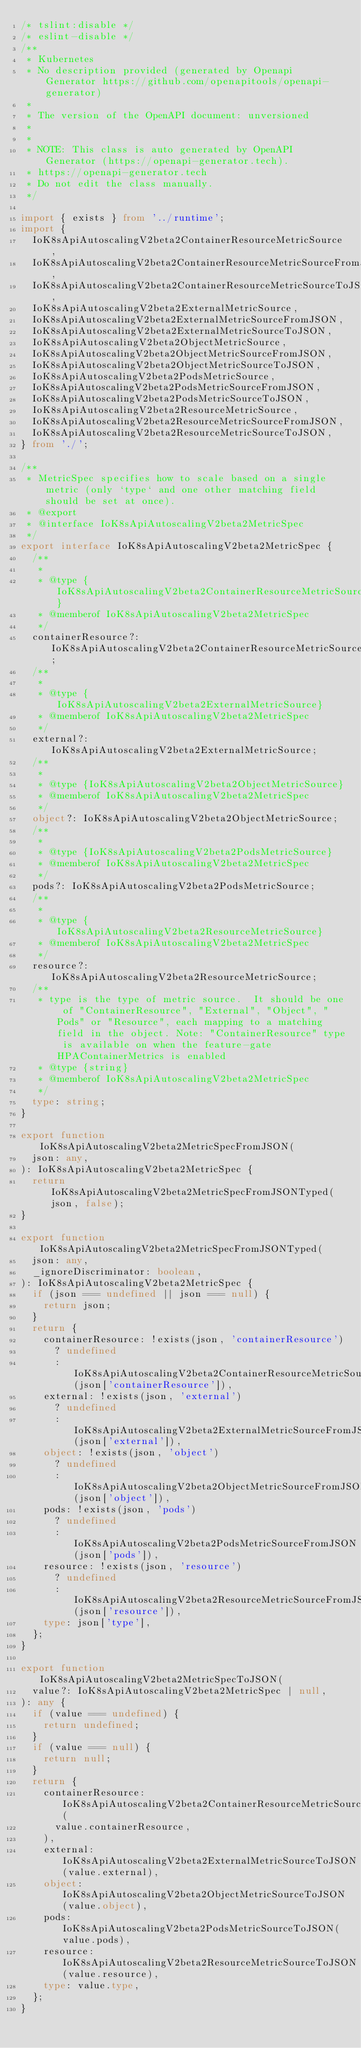<code> <loc_0><loc_0><loc_500><loc_500><_TypeScript_>/* tslint:disable */
/* eslint-disable */
/**
 * Kubernetes
 * No description provided (generated by Openapi Generator https://github.com/openapitools/openapi-generator)
 *
 * The version of the OpenAPI document: unversioned
 *
 *
 * NOTE: This class is auto generated by OpenAPI Generator (https://openapi-generator.tech).
 * https://openapi-generator.tech
 * Do not edit the class manually.
 */

import { exists } from '../runtime';
import {
  IoK8sApiAutoscalingV2beta2ContainerResourceMetricSource,
  IoK8sApiAutoscalingV2beta2ContainerResourceMetricSourceFromJSON,
  IoK8sApiAutoscalingV2beta2ContainerResourceMetricSourceToJSON,
  IoK8sApiAutoscalingV2beta2ExternalMetricSource,
  IoK8sApiAutoscalingV2beta2ExternalMetricSourceFromJSON,
  IoK8sApiAutoscalingV2beta2ExternalMetricSourceToJSON,
  IoK8sApiAutoscalingV2beta2ObjectMetricSource,
  IoK8sApiAutoscalingV2beta2ObjectMetricSourceFromJSON,
  IoK8sApiAutoscalingV2beta2ObjectMetricSourceToJSON,
  IoK8sApiAutoscalingV2beta2PodsMetricSource,
  IoK8sApiAutoscalingV2beta2PodsMetricSourceFromJSON,
  IoK8sApiAutoscalingV2beta2PodsMetricSourceToJSON,
  IoK8sApiAutoscalingV2beta2ResourceMetricSource,
  IoK8sApiAutoscalingV2beta2ResourceMetricSourceFromJSON,
  IoK8sApiAutoscalingV2beta2ResourceMetricSourceToJSON,
} from './';

/**
 * MetricSpec specifies how to scale based on a single metric (only `type` and one other matching field should be set at once).
 * @export
 * @interface IoK8sApiAutoscalingV2beta2MetricSpec
 */
export interface IoK8sApiAutoscalingV2beta2MetricSpec {
  /**
   *
   * @type {IoK8sApiAutoscalingV2beta2ContainerResourceMetricSource}
   * @memberof IoK8sApiAutoscalingV2beta2MetricSpec
   */
  containerResource?: IoK8sApiAutoscalingV2beta2ContainerResourceMetricSource;
  /**
   *
   * @type {IoK8sApiAutoscalingV2beta2ExternalMetricSource}
   * @memberof IoK8sApiAutoscalingV2beta2MetricSpec
   */
  external?: IoK8sApiAutoscalingV2beta2ExternalMetricSource;
  /**
   *
   * @type {IoK8sApiAutoscalingV2beta2ObjectMetricSource}
   * @memberof IoK8sApiAutoscalingV2beta2MetricSpec
   */
  object?: IoK8sApiAutoscalingV2beta2ObjectMetricSource;
  /**
   *
   * @type {IoK8sApiAutoscalingV2beta2PodsMetricSource}
   * @memberof IoK8sApiAutoscalingV2beta2MetricSpec
   */
  pods?: IoK8sApiAutoscalingV2beta2PodsMetricSource;
  /**
   *
   * @type {IoK8sApiAutoscalingV2beta2ResourceMetricSource}
   * @memberof IoK8sApiAutoscalingV2beta2MetricSpec
   */
  resource?: IoK8sApiAutoscalingV2beta2ResourceMetricSource;
  /**
   * type is the type of metric source.  It should be one of "ContainerResource", "External", "Object", "Pods" or "Resource", each mapping to a matching field in the object. Note: "ContainerResource" type is available on when the feature-gate HPAContainerMetrics is enabled
   * @type {string}
   * @memberof IoK8sApiAutoscalingV2beta2MetricSpec
   */
  type: string;
}

export function IoK8sApiAutoscalingV2beta2MetricSpecFromJSON(
  json: any,
): IoK8sApiAutoscalingV2beta2MetricSpec {
  return IoK8sApiAutoscalingV2beta2MetricSpecFromJSONTyped(json, false);
}

export function IoK8sApiAutoscalingV2beta2MetricSpecFromJSONTyped(
  json: any,
  _ignoreDiscriminator: boolean,
): IoK8sApiAutoscalingV2beta2MetricSpec {
  if (json === undefined || json === null) {
    return json;
  }
  return {
    containerResource: !exists(json, 'containerResource')
      ? undefined
      : IoK8sApiAutoscalingV2beta2ContainerResourceMetricSourceFromJSON(json['containerResource']),
    external: !exists(json, 'external')
      ? undefined
      : IoK8sApiAutoscalingV2beta2ExternalMetricSourceFromJSON(json['external']),
    object: !exists(json, 'object')
      ? undefined
      : IoK8sApiAutoscalingV2beta2ObjectMetricSourceFromJSON(json['object']),
    pods: !exists(json, 'pods')
      ? undefined
      : IoK8sApiAutoscalingV2beta2PodsMetricSourceFromJSON(json['pods']),
    resource: !exists(json, 'resource')
      ? undefined
      : IoK8sApiAutoscalingV2beta2ResourceMetricSourceFromJSON(json['resource']),
    type: json['type'],
  };
}

export function IoK8sApiAutoscalingV2beta2MetricSpecToJSON(
  value?: IoK8sApiAutoscalingV2beta2MetricSpec | null,
): any {
  if (value === undefined) {
    return undefined;
  }
  if (value === null) {
    return null;
  }
  return {
    containerResource: IoK8sApiAutoscalingV2beta2ContainerResourceMetricSourceToJSON(
      value.containerResource,
    ),
    external: IoK8sApiAutoscalingV2beta2ExternalMetricSourceToJSON(value.external),
    object: IoK8sApiAutoscalingV2beta2ObjectMetricSourceToJSON(value.object),
    pods: IoK8sApiAutoscalingV2beta2PodsMetricSourceToJSON(value.pods),
    resource: IoK8sApiAutoscalingV2beta2ResourceMetricSourceToJSON(value.resource),
    type: value.type,
  };
}
</code> 